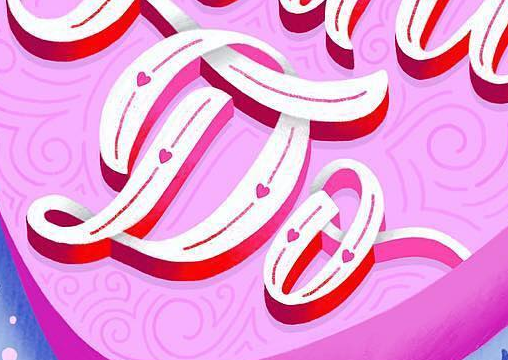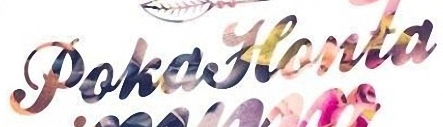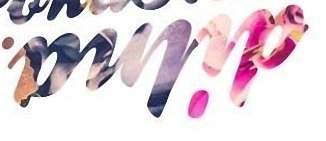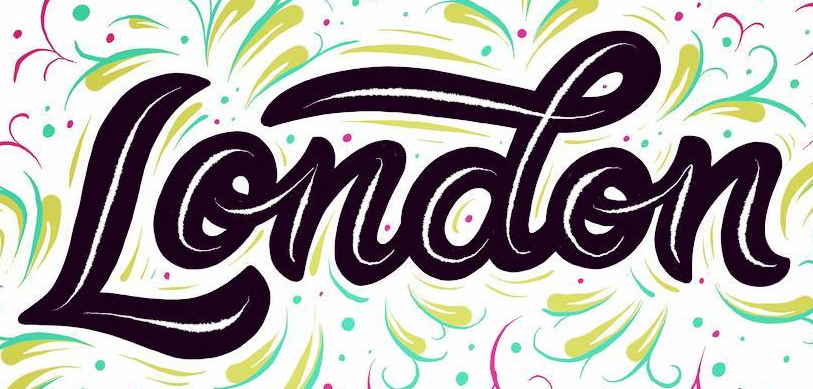Transcribe the words shown in these images in order, separated by a semicolon. Do; PokaHonta; dilna; London 